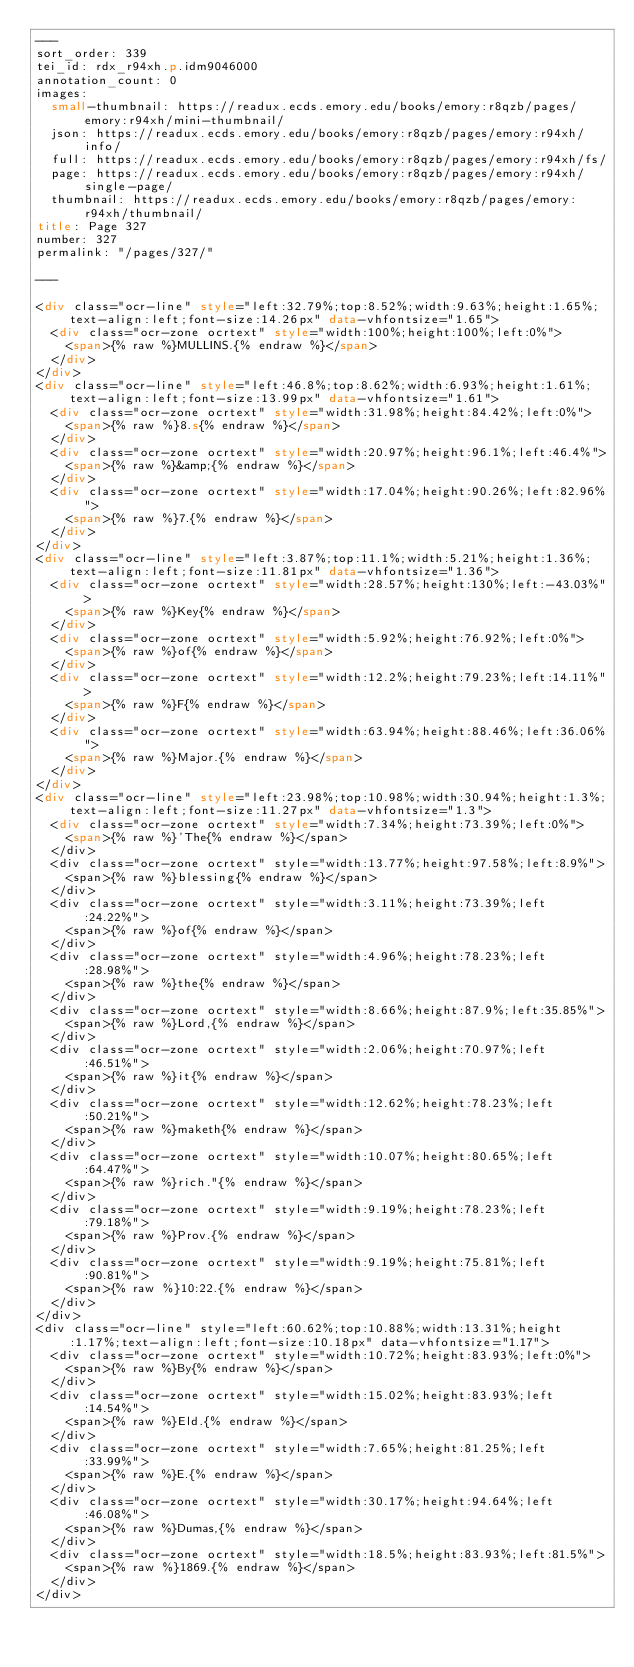<code> <loc_0><loc_0><loc_500><loc_500><_HTML_>---
sort_order: 339
tei_id: rdx_r94xh.p.idm9046000
annotation_count: 0
images:
  small-thumbnail: https://readux.ecds.emory.edu/books/emory:r8qzb/pages/emory:r94xh/mini-thumbnail/
  json: https://readux.ecds.emory.edu/books/emory:r8qzb/pages/emory:r94xh/info/
  full: https://readux.ecds.emory.edu/books/emory:r8qzb/pages/emory:r94xh/fs/
  page: https://readux.ecds.emory.edu/books/emory:r8qzb/pages/emory:r94xh/single-page/
  thumbnail: https://readux.ecds.emory.edu/books/emory:r8qzb/pages/emory:r94xh/thumbnail/
title: Page 327
number: 327
permalink: "/pages/327/"

---

<div class="ocr-line" style="left:32.79%;top:8.52%;width:9.63%;height:1.65%;text-align:left;font-size:14.26px" data-vhfontsize="1.65">
  <div class="ocr-zone ocrtext" style="width:100%;height:100%;left:0%">
    <span>{% raw %}MULLINS.{% endraw %}</span>
  </div>
</div>
<div class="ocr-line" style="left:46.8%;top:8.62%;width:6.93%;height:1.61%;text-align:left;font-size:13.99px" data-vhfontsize="1.61">
  <div class="ocr-zone ocrtext" style="width:31.98%;height:84.42%;left:0%">
    <span>{% raw %}8.s{% endraw %}</span>
  </div>
  <div class="ocr-zone ocrtext" style="width:20.97%;height:96.1%;left:46.4%">
    <span>{% raw %}&amp;{% endraw %}</span>
  </div>
  <div class="ocr-zone ocrtext" style="width:17.04%;height:90.26%;left:82.96%">
    <span>{% raw %}7.{% endraw %}</span>
  </div>
</div>
<div class="ocr-line" style="left:3.87%;top:11.1%;width:5.21%;height:1.36%;text-align:left;font-size:11.81px" data-vhfontsize="1.36">
  <div class="ocr-zone ocrtext" style="width:28.57%;height:130%;left:-43.03%">
    <span>{% raw %}Key{% endraw %}</span>
  </div>
  <div class="ocr-zone ocrtext" style="width:5.92%;height:76.92%;left:0%">
    <span>{% raw %}of{% endraw %}</span>
  </div>
  <div class="ocr-zone ocrtext" style="width:12.2%;height:79.23%;left:14.11%">
    <span>{% raw %}F{% endraw %}</span>
  </div>
  <div class="ocr-zone ocrtext" style="width:63.94%;height:88.46%;left:36.06%">
    <span>{% raw %}Major.{% endraw %}</span>
  </div>
</div>
<div class="ocr-line" style="left:23.98%;top:10.98%;width:30.94%;height:1.3%;text-align:left;font-size:11.27px" data-vhfontsize="1.3">
  <div class="ocr-zone ocrtext" style="width:7.34%;height:73.39%;left:0%">
    <span>{% raw %}'The{% endraw %}</span>
  </div>
  <div class="ocr-zone ocrtext" style="width:13.77%;height:97.58%;left:8.9%">
    <span>{% raw %}blessing{% endraw %}</span>
  </div>
  <div class="ocr-zone ocrtext" style="width:3.11%;height:73.39%;left:24.22%">
    <span>{% raw %}of{% endraw %}</span>
  </div>
  <div class="ocr-zone ocrtext" style="width:4.96%;height:78.23%;left:28.98%">
    <span>{% raw %}the{% endraw %}</span>
  </div>
  <div class="ocr-zone ocrtext" style="width:8.66%;height:87.9%;left:35.85%">
    <span>{% raw %}Lord,{% endraw %}</span>
  </div>
  <div class="ocr-zone ocrtext" style="width:2.06%;height:70.97%;left:46.51%">
    <span>{% raw %}it{% endraw %}</span>
  </div>
  <div class="ocr-zone ocrtext" style="width:12.62%;height:78.23%;left:50.21%">
    <span>{% raw %}maketh{% endraw %}</span>
  </div>
  <div class="ocr-zone ocrtext" style="width:10.07%;height:80.65%;left:64.47%">
    <span>{% raw %}rich."{% endraw %}</span>
  </div>
  <div class="ocr-zone ocrtext" style="width:9.19%;height:78.23%;left:79.18%">
    <span>{% raw %}Prov.{% endraw %}</span>
  </div>
  <div class="ocr-zone ocrtext" style="width:9.19%;height:75.81%;left:90.81%">
    <span>{% raw %}10:22.{% endraw %}</span>
  </div>
</div>
<div class="ocr-line" style="left:60.62%;top:10.88%;width:13.31%;height:1.17%;text-align:left;font-size:10.18px" data-vhfontsize="1.17">
  <div class="ocr-zone ocrtext" style="width:10.72%;height:83.93%;left:0%">
    <span>{% raw %}By{% endraw %}</span>
  </div>
  <div class="ocr-zone ocrtext" style="width:15.02%;height:83.93%;left:14.54%">
    <span>{% raw %}Eld.{% endraw %}</span>
  </div>
  <div class="ocr-zone ocrtext" style="width:7.65%;height:81.25%;left:33.99%">
    <span>{% raw %}E.{% endraw %}</span>
  </div>
  <div class="ocr-zone ocrtext" style="width:30.17%;height:94.64%;left:46.08%">
    <span>{% raw %}Dumas,{% endraw %}</span>
  </div>
  <div class="ocr-zone ocrtext" style="width:18.5%;height:83.93%;left:81.5%">
    <span>{% raw %}1869.{% endraw %}</span>
  </div>
</div></code> 